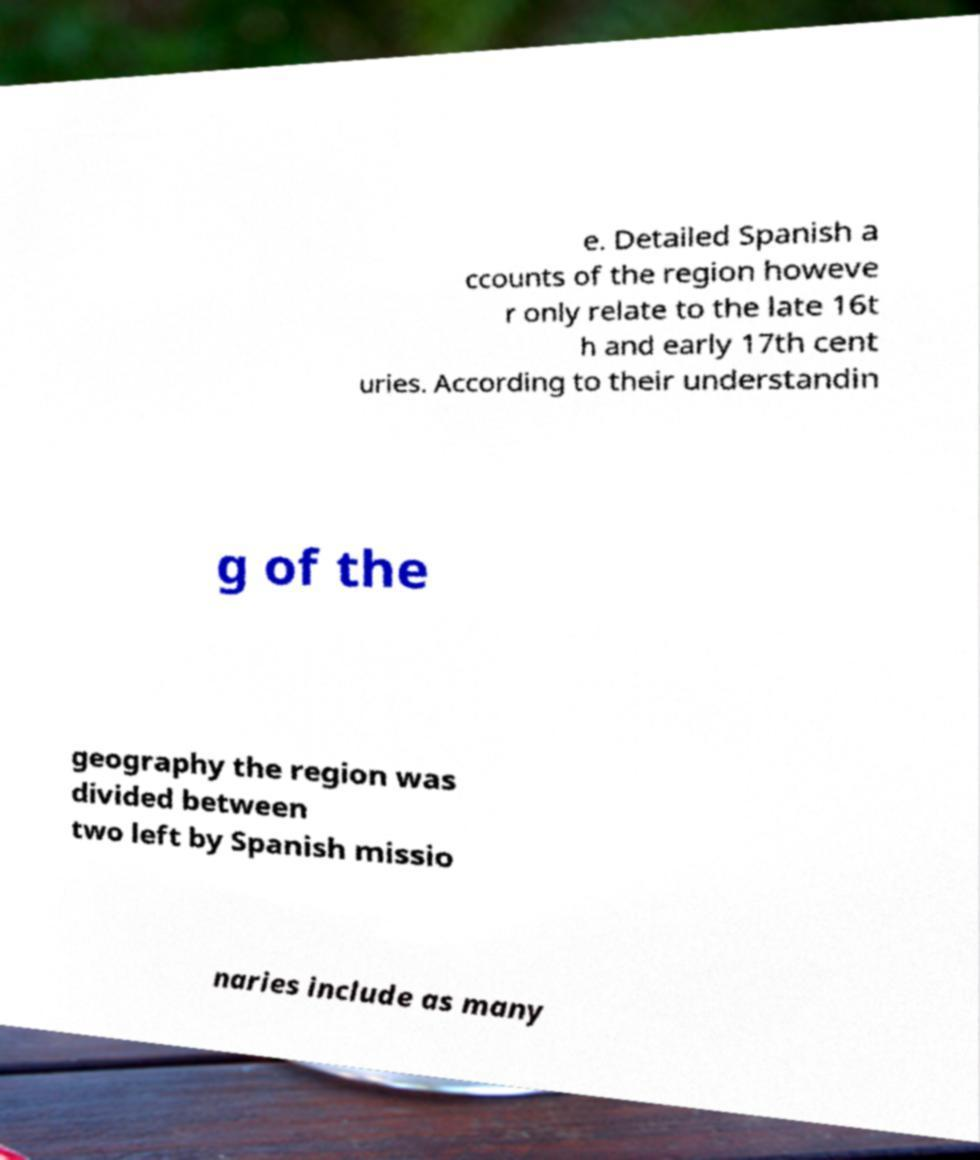Please identify and transcribe the text found in this image. e. Detailed Spanish a ccounts of the region howeve r only relate to the late 16t h and early 17th cent uries. According to their understandin g of the geography the region was divided between two left by Spanish missio naries include as many 